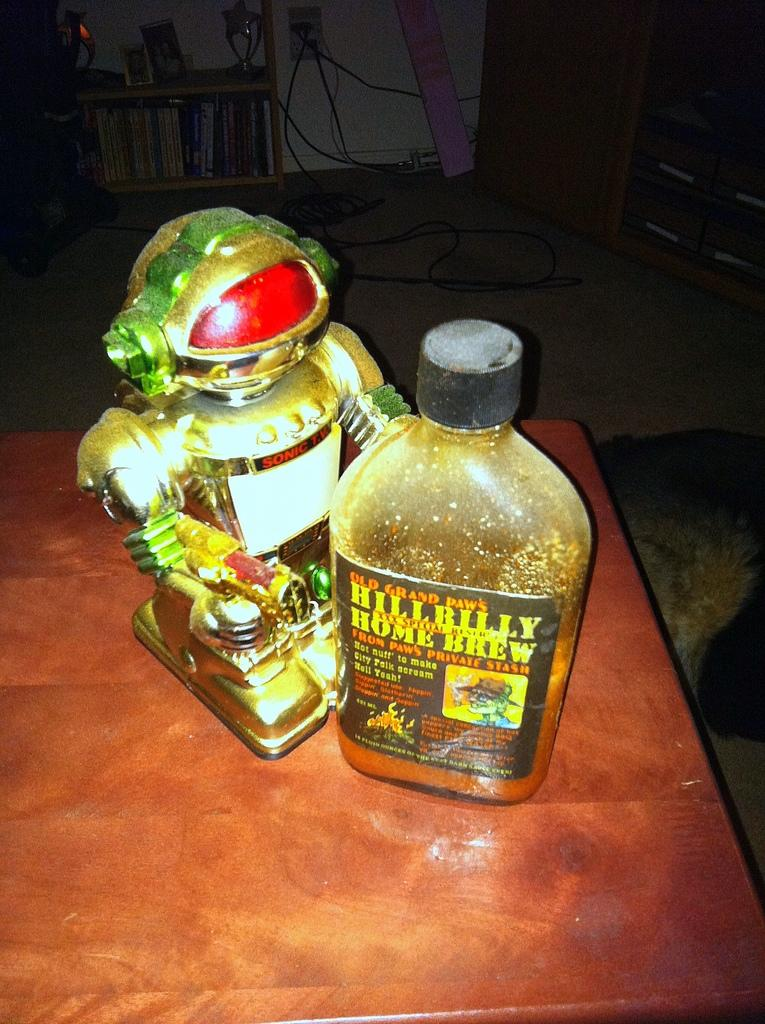<image>
Give a short and clear explanation of the subsequent image. Aa bottle of Old Grandpaw's Hillbilly home brew sits beside a robot on a table. 